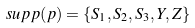<formula> <loc_0><loc_0><loc_500><loc_500>s u p p ( p ) = \{ S _ { 1 } , S _ { 2 } , S _ { 3 } , Y , Z \}</formula> 